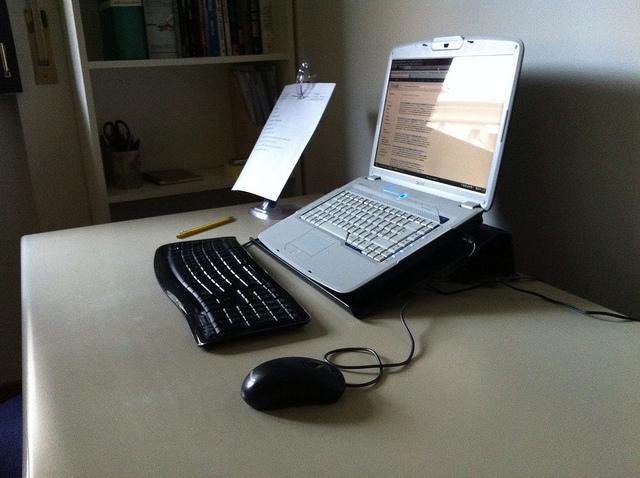How many books are there?
Give a very brief answer. 2. How many keyboards are visible?
Give a very brief answer. 2. How many people are there?
Give a very brief answer. 0. 